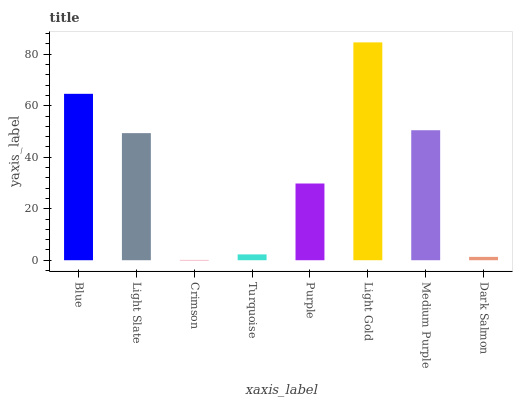Is Light Slate the minimum?
Answer yes or no. No. Is Light Slate the maximum?
Answer yes or no. No. Is Blue greater than Light Slate?
Answer yes or no. Yes. Is Light Slate less than Blue?
Answer yes or no. Yes. Is Light Slate greater than Blue?
Answer yes or no. No. Is Blue less than Light Slate?
Answer yes or no. No. Is Light Slate the high median?
Answer yes or no. Yes. Is Purple the low median?
Answer yes or no. Yes. Is Medium Purple the high median?
Answer yes or no. No. Is Crimson the low median?
Answer yes or no. No. 